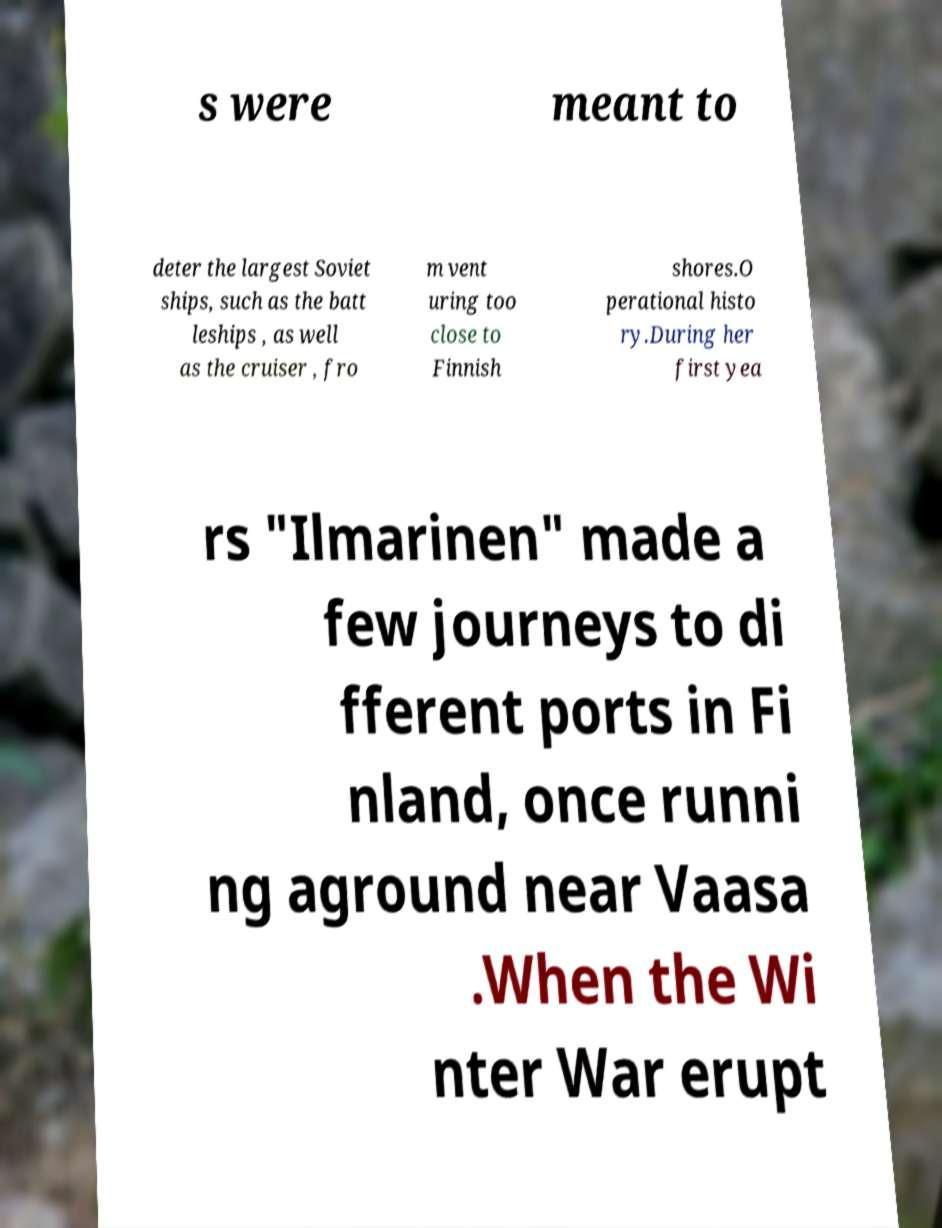Could you extract and type out the text from this image? s were meant to deter the largest Soviet ships, such as the batt leships , as well as the cruiser , fro m vent uring too close to Finnish shores.O perational histo ry.During her first yea rs "Ilmarinen" made a few journeys to di fferent ports in Fi nland, once runni ng aground near Vaasa .When the Wi nter War erupt 